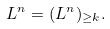Convert formula to latex. <formula><loc_0><loc_0><loc_500><loc_500>L ^ { n } = ( L ^ { n } ) _ { \geq k } .</formula> 